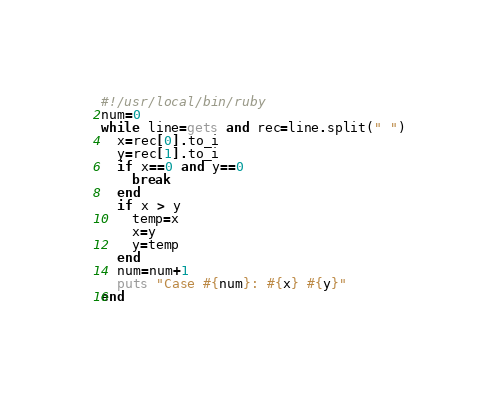Convert code to text. <code><loc_0><loc_0><loc_500><loc_500><_Ruby_>#!/usr/local/bin/ruby
num=0
while line=gets and rec=line.split(" ")
  x=rec[0].to_i
  y=rec[1].to_i
  if x==0 and y==0 
    break 
  end
  if x > y
    temp=x
    x=y
    y=temp
  end
  num=num+1
  puts "Case #{num}: #{x} #{y}"
end </code> 